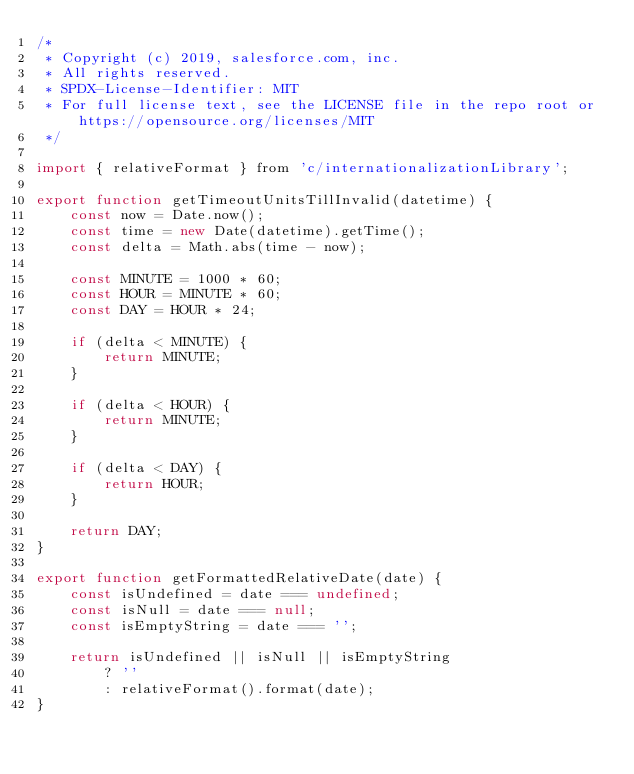Convert code to text. <code><loc_0><loc_0><loc_500><loc_500><_JavaScript_>/*
 * Copyright (c) 2019, salesforce.com, inc.
 * All rights reserved.
 * SPDX-License-Identifier: MIT
 * For full license text, see the LICENSE file in the repo root or https://opensource.org/licenses/MIT
 */

import { relativeFormat } from 'c/internationalizationLibrary';

export function getTimeoutUnitsTillInvalid(datetime) {
    const now = Date.now();
    const time = new Date(datetime).getTime();
    const delta = Math.abs(time - now);

    const MINUTE = 1000 * 60;
    const HOUR = MINUTE * 60;
    const DAY = HOUR * 24;

    if (delta < MINUTE) {
        return MINUTE;
    }

    if (delta < HOUR) {
        return MINUTE;
    }

    if (delta < DAY) {
        return HOUR;
    }

    return DAY;
}

export function getFormattedRelativeDate(date) {
    const isUndefined = date === undefined;
    const isNull = date === null;
    const isEmptyString = date === '';

    return isUndefined || isNull || isEmptyString
        ? ''
        : relativeFormat().format(date);
}
</code> 